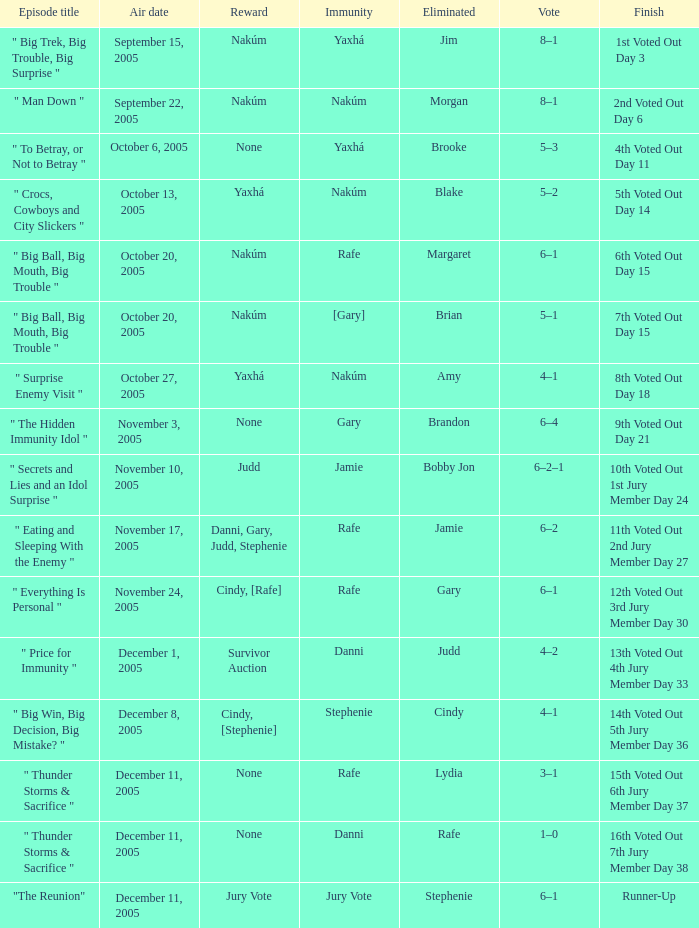How many air dates were there when Morgan was eliminated? 1.0. 